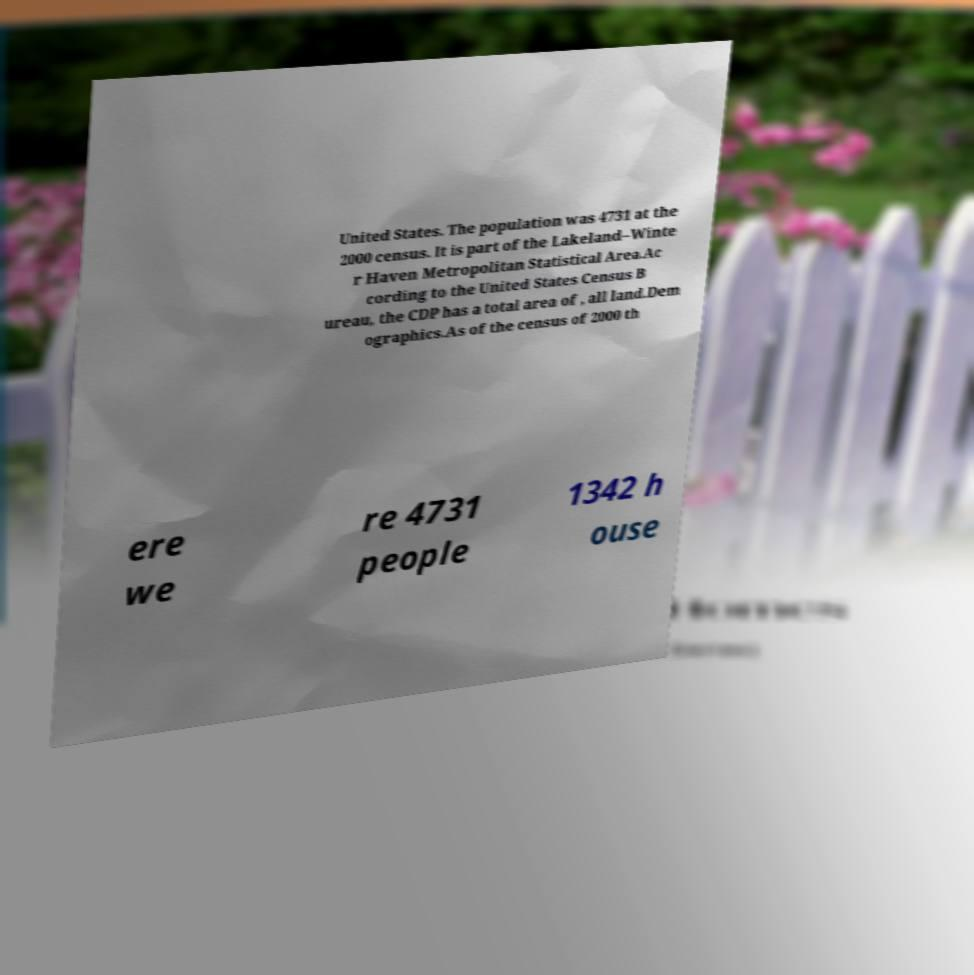Please read and relay the text visible in this image. What does it say? United States. The population was 4731 at the 2000 census. It is part of the Lakeland–Winte r Haven Metropolitan Statistical Area.Ac cording to the United States Census B ureau, the CDP has a total area of , all land.Dem ographics.As of the census of 2000 th ere we re 4731 people 1342 h ouse 